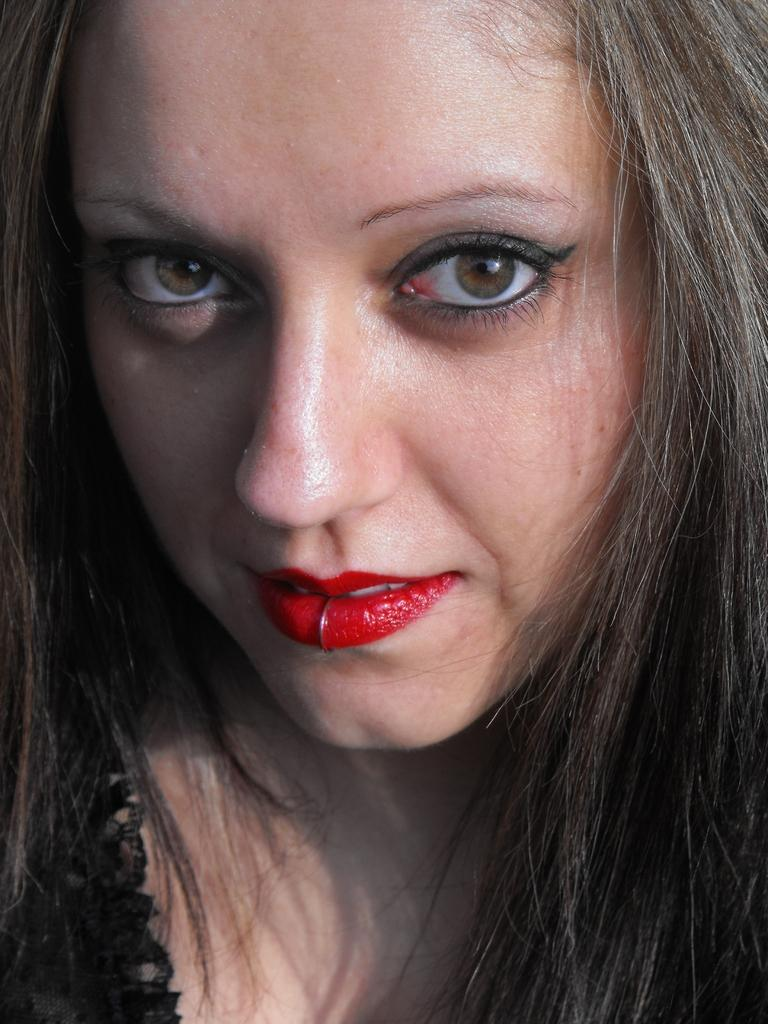What is the main subject of the image? The main subject of the image is a lady. Can you see any fish swimming near the lady in the image? There is no fish present in the image. Is there a kitten visible in the image, interacting with the lady? There is no kitten present in the image. 